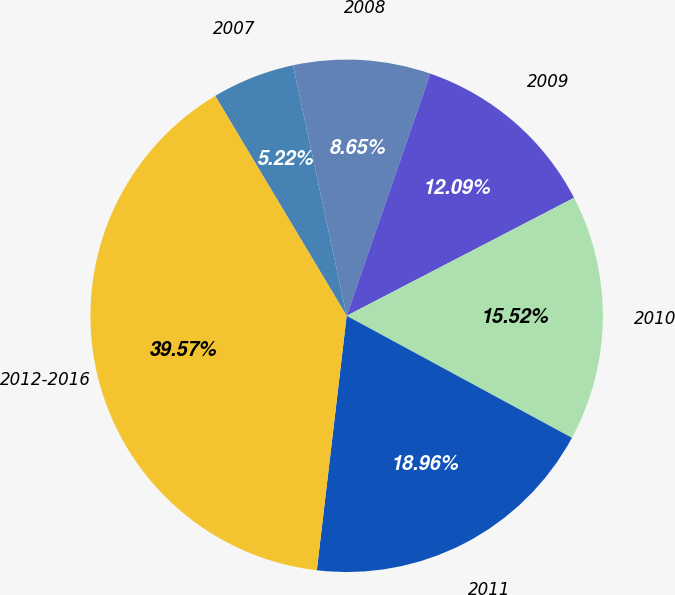Convert chart to OTSL. <chart><loc_0><loc_0><loc_500><loc_500><pie_chart><fcel>2007<fcel>2008<fcel>2009<fcel>2010<fcel>2011<fcel>2012-2016<nl><fcel>5.22%<fcel>8.65%<fcel>12.09%<fcel>15.52%<fcel>18.96%<fcel>39.57%<nl></chart> 